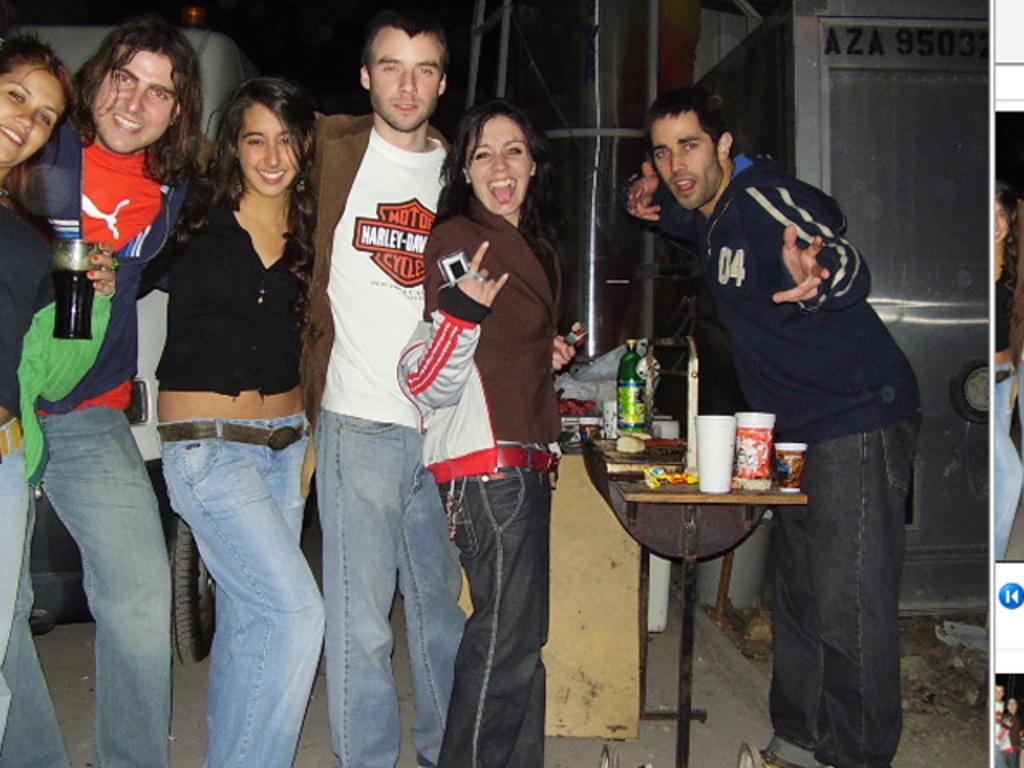In one or two sentences, can you explain what this image depicts? In the center of the picture there are people standing, few are holding glasses. In the center of the picture there is a table, on the table there are glasses, bottles and other object. In the background there is a vehicle, iron frame and box. On the right it is a collage. On the right there is a woman and a skip button. 